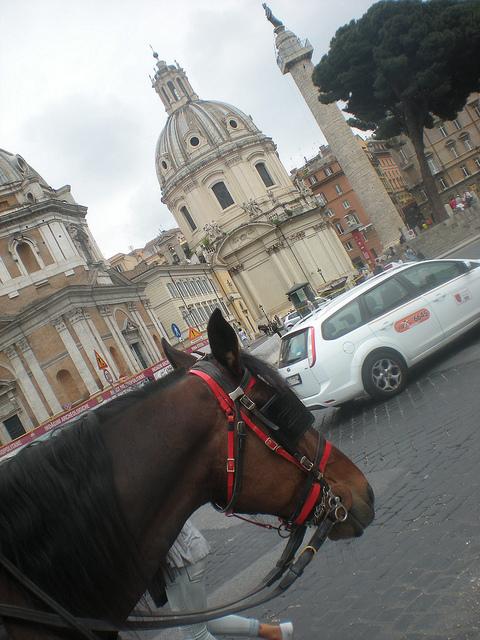How many yellow signs are in the photo?
Give a very brief answer. 1. Can this animal swim?
Keep it brief. No. Is the street paved?
Concise answer only. Yes. What is over the horses face?
Give a very brief answer. Blinders. What animals head is in this picture?
Be succinct. Horse. What color is the roof?
Keep it brief. White. 